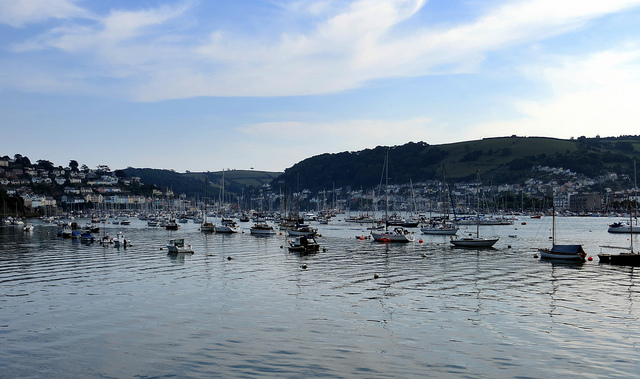<image>What marina are the boats at? I don't know which marina the boats are at. It could be multiple places such as Greece, Long Beach, Marina Del Mar, Monterey, Pearl Harbor, or Santa Marina. What marina are the boats at? I don't know what marina the boats are at. It could be any of the mentioned options. 